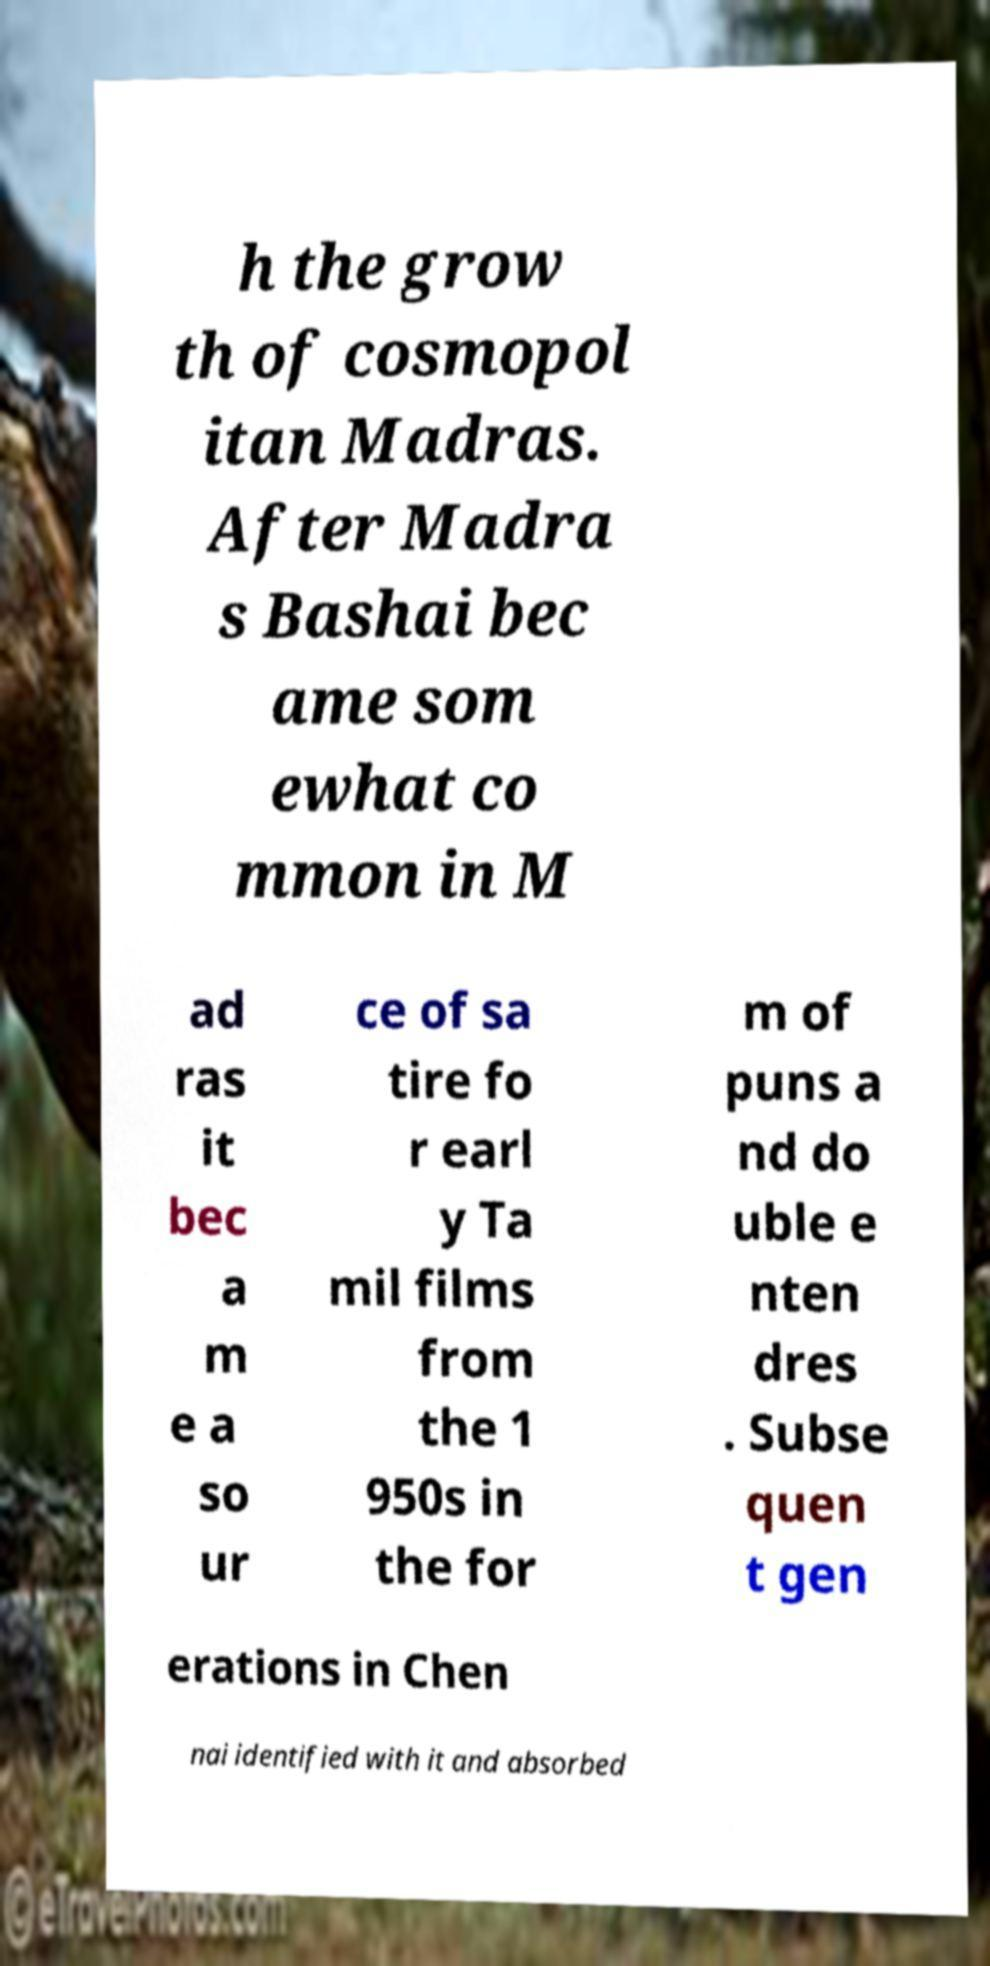Please identify and transcribe the text found in this image. h the grow th of cosmopol itan Madras. After Madra s Bashai bec ame som ewhat co mmon in M ad ras it bec a m e a so ur ce of sa tire fo r earl y Ta mil films from the 1 950s in the for m of puns a nd do uble e nten dres . Subse quen t gen erations in Chen nai identified with it and absorbed 